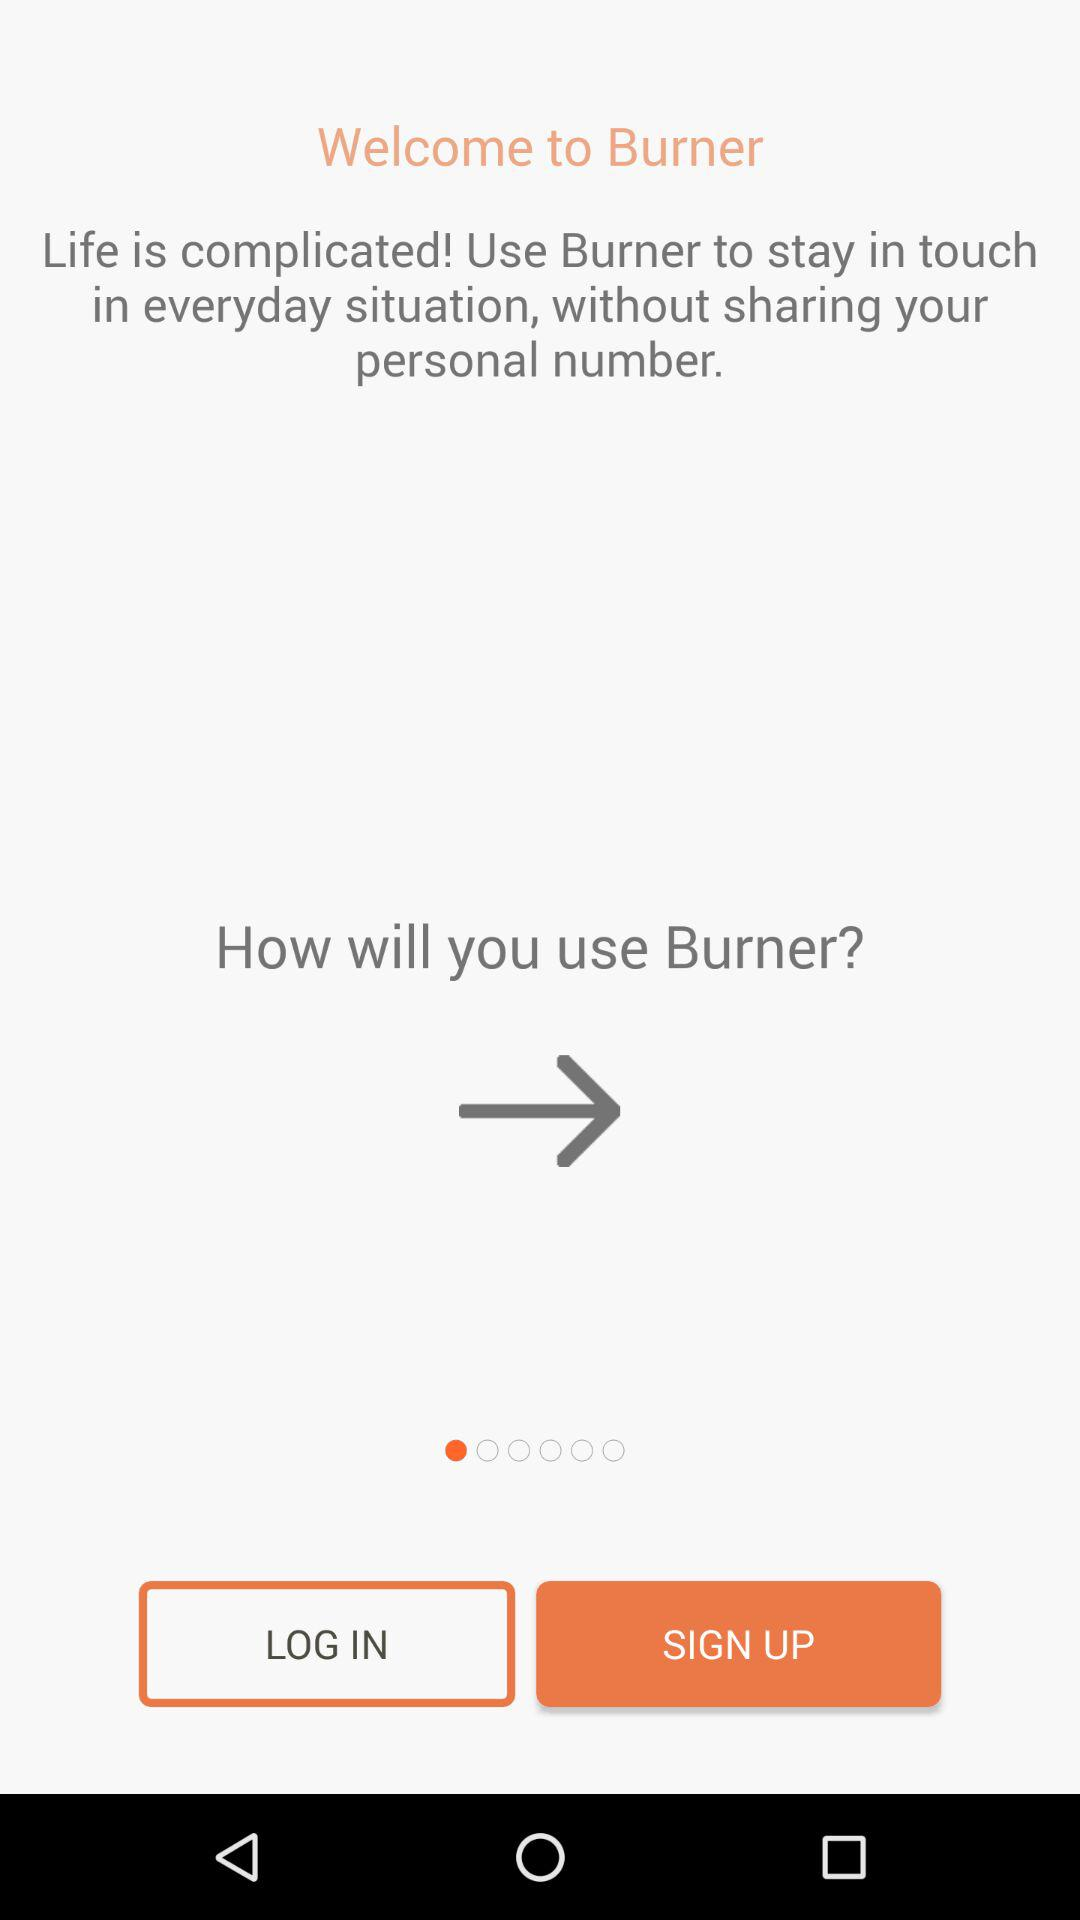What is the use of the "Burner" app? The "Burner" app is used "to stay in touch in everyday situation, without sharing your personal number.". 